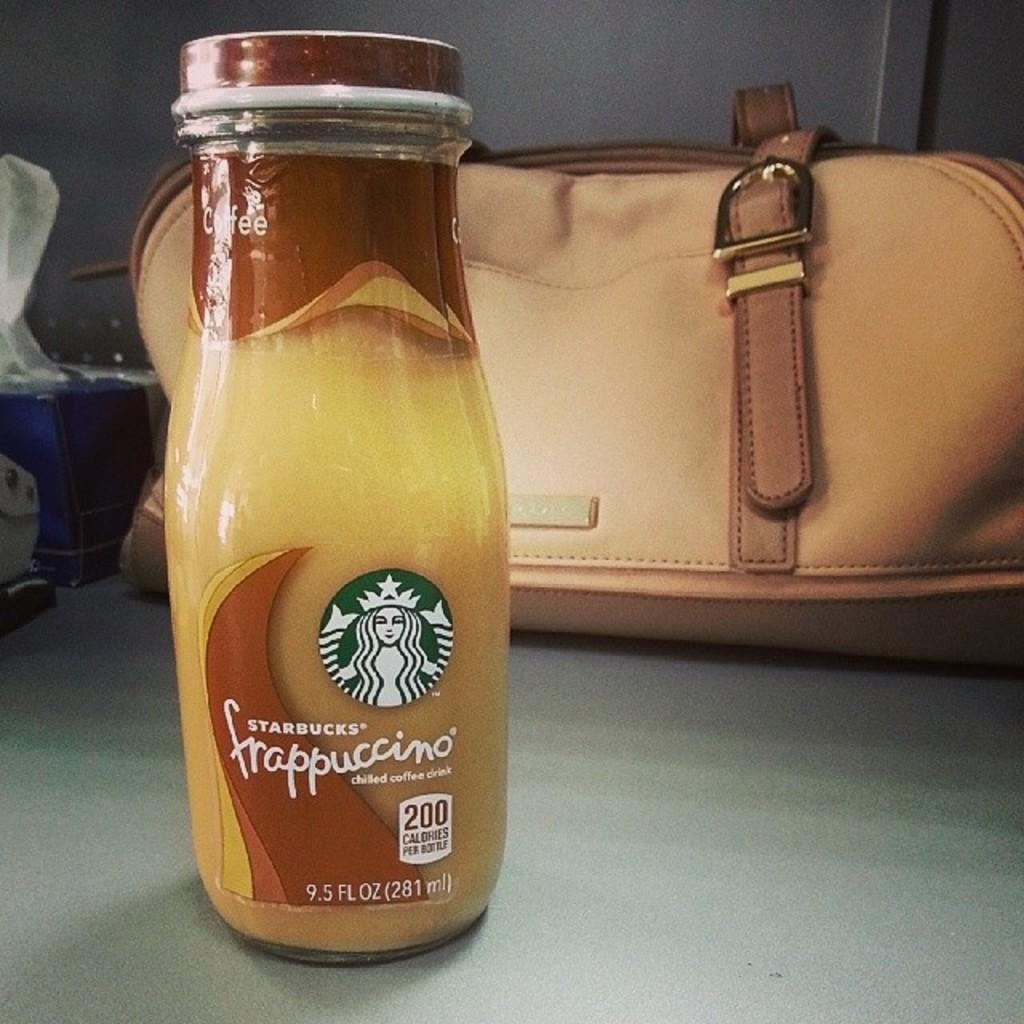What type of bottle is visible in the image? There is a Cappuccino bottle in the image. What else can be seen behind the Cappuccino bottle? There is a luggage bag behind the Cappuccino bottle. Can you see a volleyball being played in the image? No, there is no volleyball or any indication of a game being played in the image. 